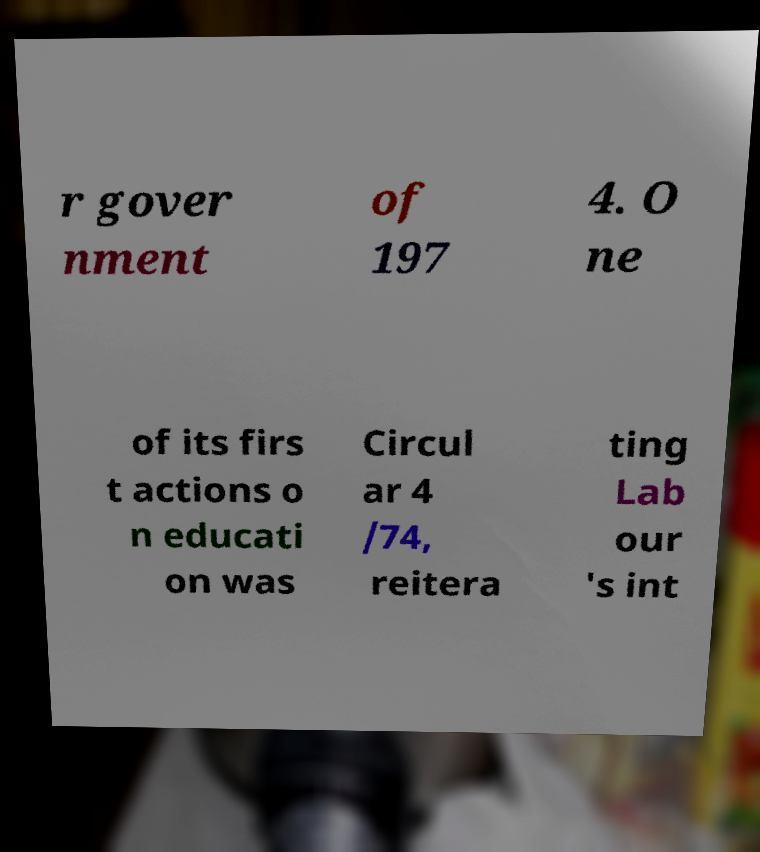For documentation purposes, I need the text within this image transcribed. Could you provide that? r gover nment of 197 4. O ne of its firs t actions o n educati on was Circul ar 4 /74, reitera ting Lab our 's int 